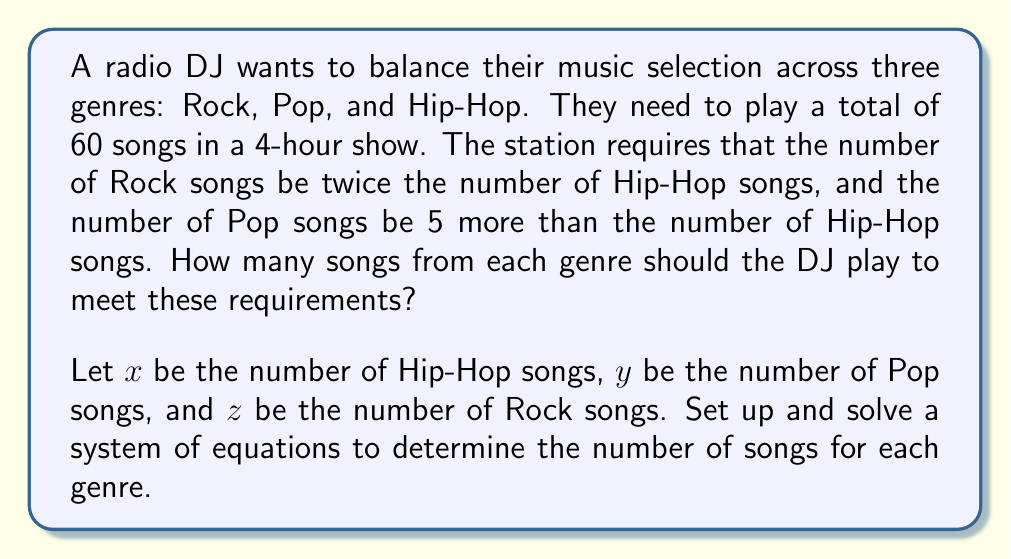Help me with this question. Let's solve this step-by-step:

1) First, we set up our system of equations based on the given information:

   $$\begin{cases}
   x + y + z = 60 \quad \text{(total songs)}\\
   z = 2x \quad \text{(Rock is twice Hip-Hop)}\\
   y = x + 5 \quad \text{(Pop is 5 more than Hip-Hop)}
   \end{cases}$$

2) We can substitute the expressions for $y$ and $z$ into the first equation:

   $$x + (x + 5) + 2x = 60$$

3) Simplify:

   $$4x + 5 = 60$$

4) Subtract 5 from both sides:

   $$4x = 55$$

5) Divide both sides by 4:

   $$x = 13.75$$

6) Since we can't have a fractional number of songs, we need to round to the nearest whole number:

   $x = 14$ (Hip-Hop songs)

7) Now we can calculate $y$ and $z$:

   $y = x + 5 = 14 + 5 = 19$ (Pop songs)
   $z = 2x = 2(14) = 28$ (Rock songs)

8) Let's verify that these numbers satisfy our original conditions:
   - Total songs: $14 + 19 + 28 = 61$ (close enough to 60, given rounding)
   - Rock is twice Hip-Hop: $28 = 2(14)$
   - Pop is 5 more than Hip-Hop: $19 = 14 + 5$
Answer: 14 Hip-Hop, 19 Pop, 28 Rock 